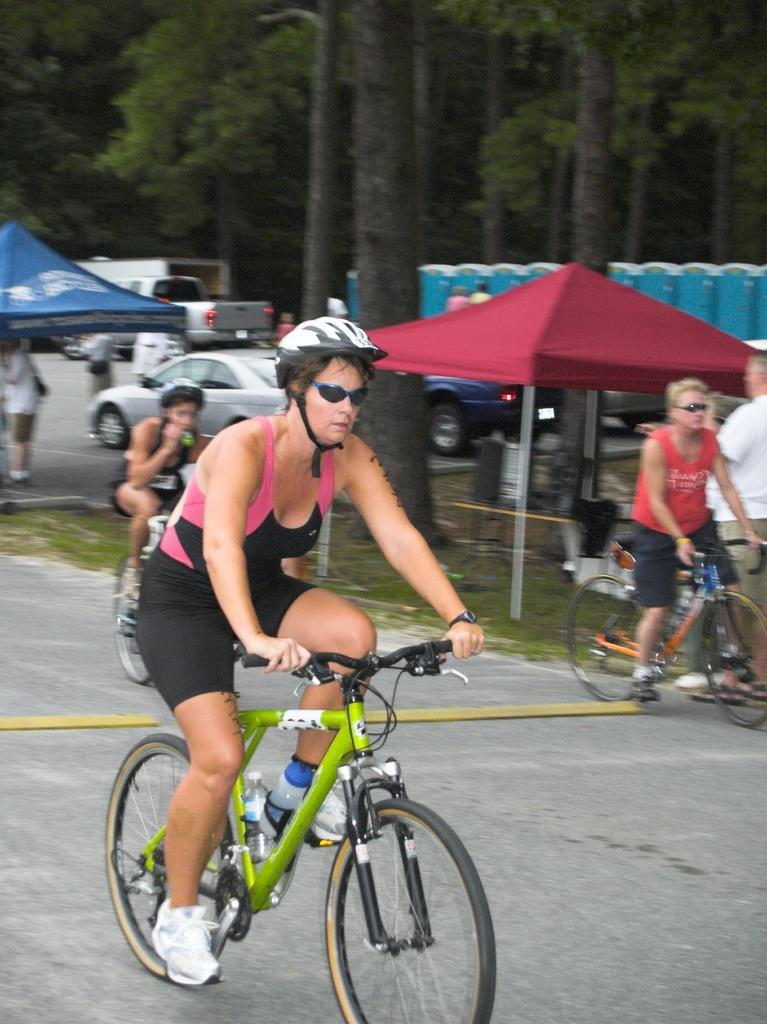Could you give a brief overview of what you see in this image? This is a picture taken in the outdoors. It is sunny. A group of people riding their bicycles on road. Behind the people there are cars parking on road and tents. Background of these people there are trees. 